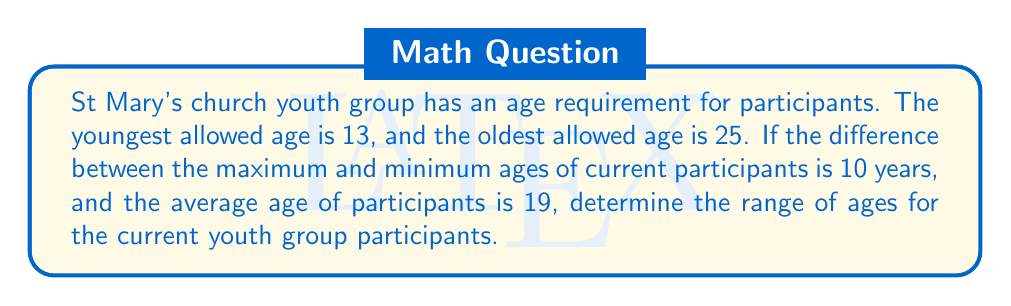What is the answer to this math problem? Let's approach this step-by-step:

1) Let $x$ be the minimum age and $y$ be the maximum age of current participants.

2) Given information:
   - Difference between max and min: $y - x = 10$
   - Average age: $(x + y) / 2 = 19$

3) From the average age, we can derive:
   $x + y = 38$

4) Substituting $y = x + 10$ (from the difference) into this equation:
   $x + (x + 10) = 38$
   $2x + 10 = 38$
   $2x = 28$
   $x = 14$

5) If $x = 14$, then $y = x + 10 = 24$

6) Verify:
   - Difference: $24 - 14 = 10$ ✓
   - Average: $(14 + 24) / 2 = 19$ ✓

7) The range is therefore $[14, 24]$, which falls within the allowed range of $[13, 25]$ for the youth group.
Answer: $[14, 24]$ 